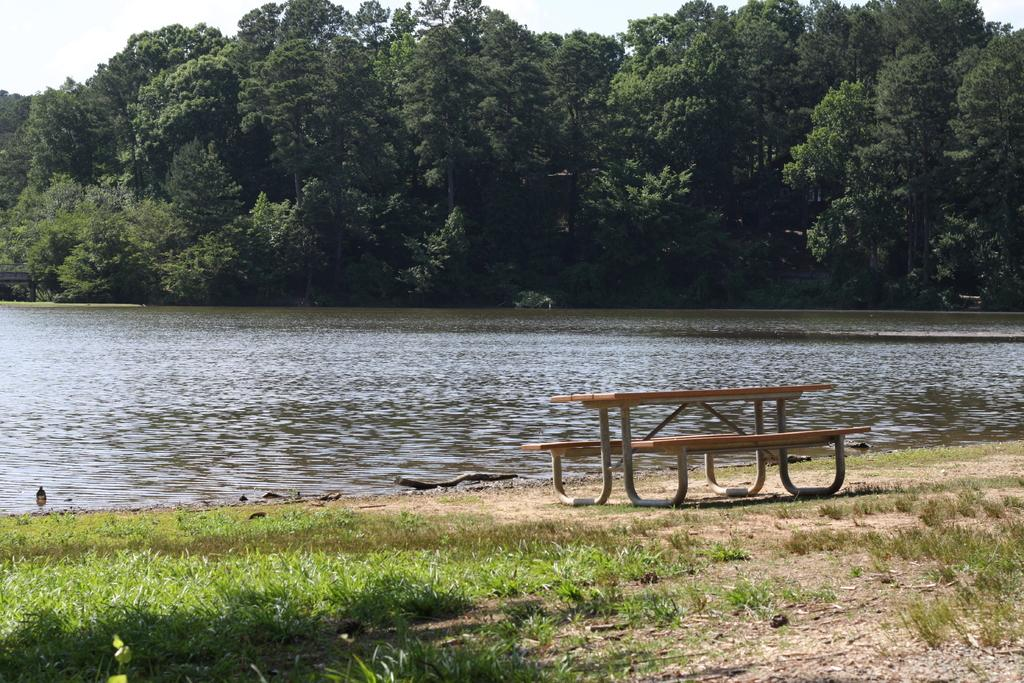What type of furniture is present in the image? There is a table in the image. What material is near the water in the image? There is wood near the water in the image. What type of vegetation can be seen in the image? There are trees visible in the image. What type of ground cover is present in the image? There is grass in the image. How much money is being exchanged between the family members in the image? There is no mention of money or family members in the image; it only features a table, wood near the water, trees, and grass. Can you describe the physical interaction between the family members in the image? There are no family members present in the image, so it is not possible to describe any physical interactions between them. 